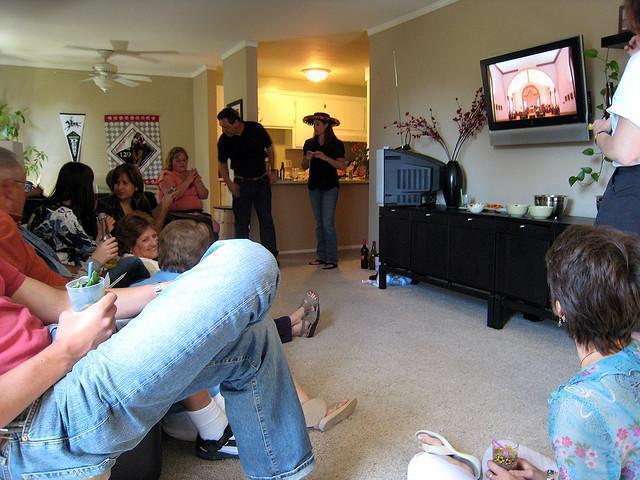What are the people looking at in the room?
Answer the question by selecting the correct answer among the 4 following choices and explain your choice with a short sentence. The answer should be formatted with the following format: `Answer: choice
Rationale: rationale.`
Options: Painting, window, television, artwork. Answer: television.
Rationale: People are gathered around a television that is turned on. 